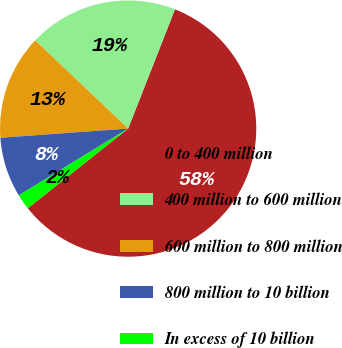<chart> <loc_0><loc_0><loc_500><loc_500><pie_chart><fcel>0 to 400 million<fcel>400 million to 600 million<fcel>600 million to 800 million<fcel>800 million to 10 billion<fcel>In excess of 10 billion<nl><fcel>58.37%<fcel>18.87%<fcel>13.23%<fcel>7.59%<fcel>1.95%<nl></chart> 